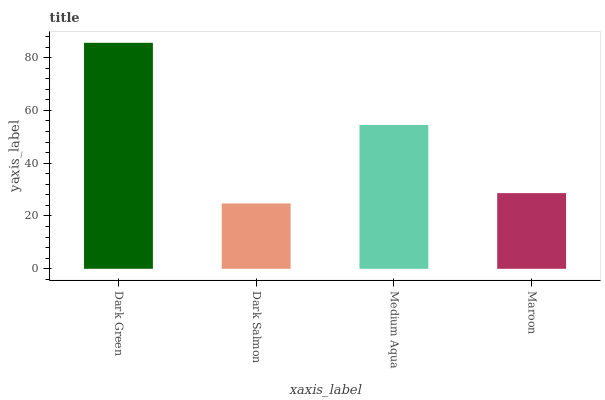Is Dark Salmon the minimum?
Answer yes or no. Yes. Is Dark Green the maximum?
Answer yes or no. Yes. Is Medium Aqua the minimum?
Answer yes or no. No. Is Medium Aqua the maximum?
Answer yes or no. No. Is Medium Aqua greater than Dark Salmon?
Answer yes or no. Yes. Is Dark Salmon less than Medium Aqua?
Answer yes or no. Yes. Is Dark Salmon greater than Medium Aqua?
Answer yes or no. No. Is Medium Aqua less than Dark Salmon?
Answer yes or no. No. Is Medium Aqua the high median?
Answer yes or no. Yes. Is Maroon the low median?
Answer yes or no. Yes. Is Dark Salmon the high median?
Answer yes or no. No. Is Medium Aqua the low median?
Answer yes or no. No. 